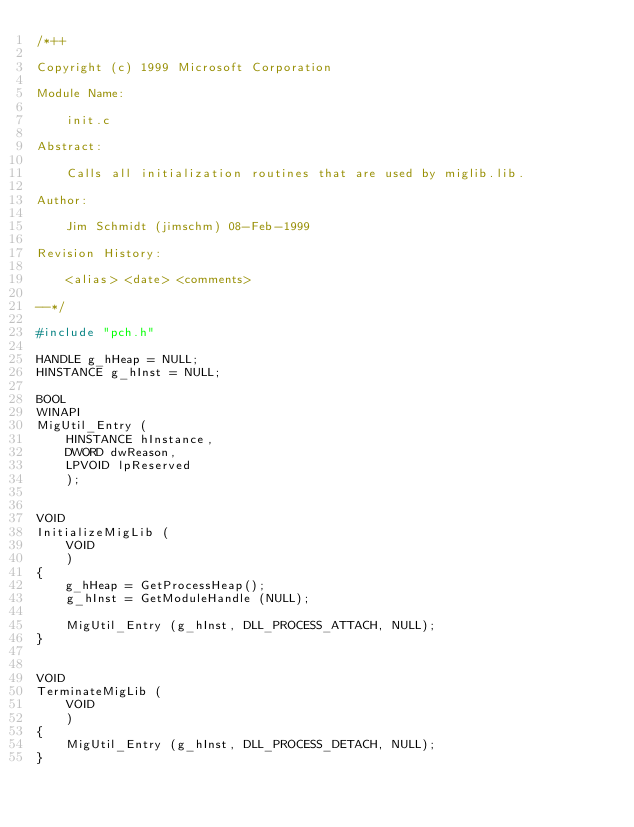<code> <loc_0><loc_0><loc_500><loc_500><_C_>/*++

Copyright (c) 1999 Microsoft Corporation

Module Name:

    init.c

Abstract:

    Calls all initialization routines that are used by miglib.lib.

Author:

    Jim Schmidt (jimschm) 08-Feb-1999

Revision History:

    <alias> <date> <comments>

--*/

#include "pch.h"

HANDLE g_hHeap = NULL;
HINSTANCE g_hInst = NULL;

BOOL
WINAPI
MigUtil_Entry (
    HINSTANCE hInstance,
    DWORD dwReason,
    LPVOID lpReserved
    );


VOID
InitializeMigLib (
    VOID
    )
{
    g_hHeap = GetProcessHeap();
    g_hInst = GetModuleHandle (NULL);

    MigUtil_Entry (g_hInst, DLL_PROCESS_ATTACH, NULL);
}


VOID
TerminateMigLib (
    VOID
    )
{
    MigUtil_Entry (g_hInst, DLL_PROCESS_DETACH, NULL);
}
</code> 